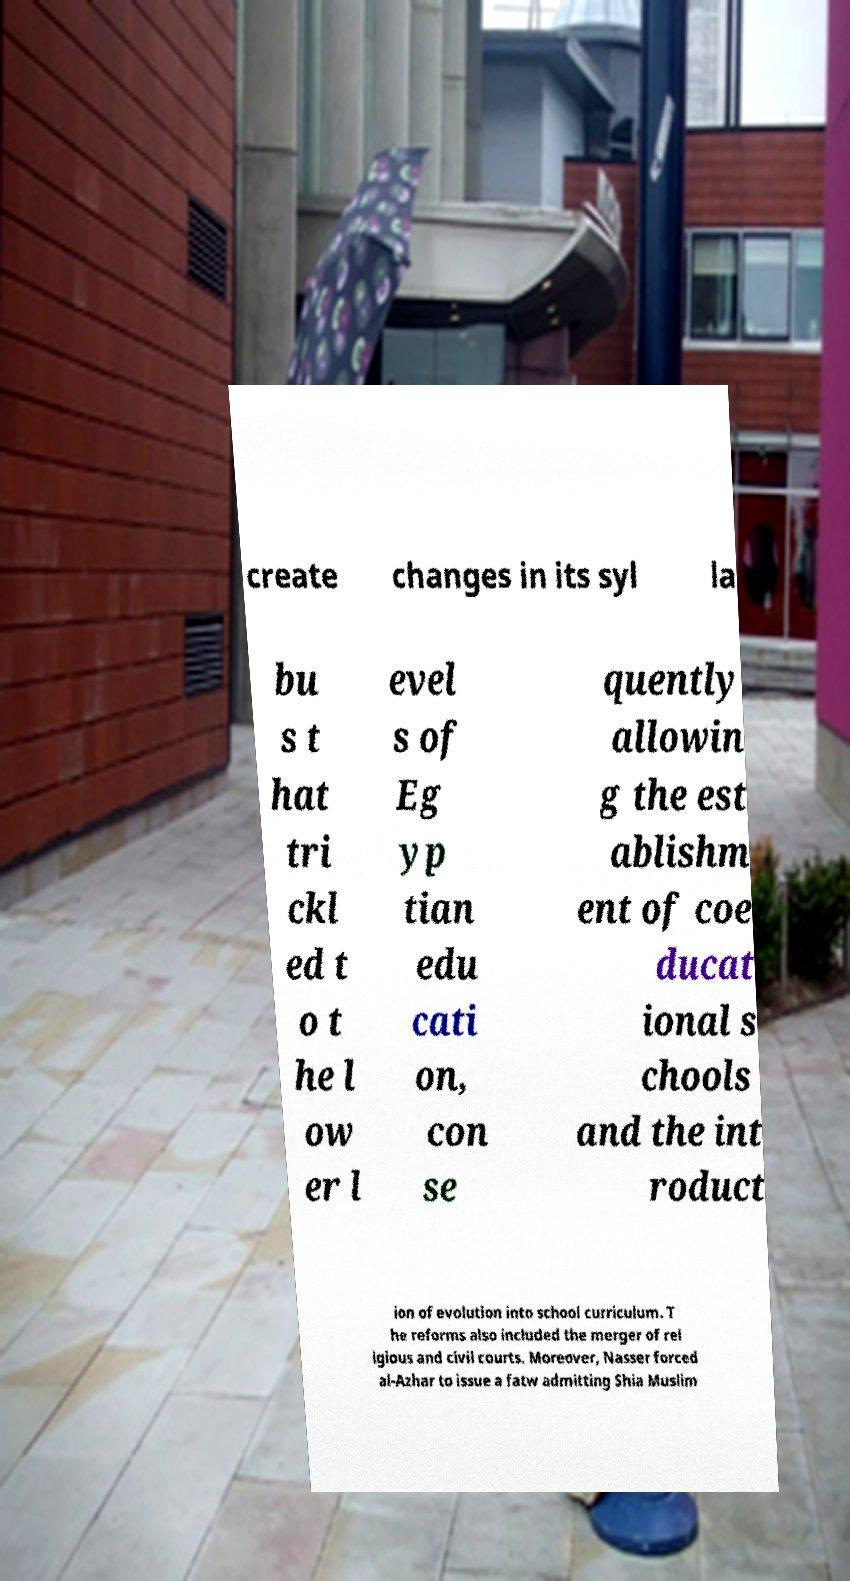I need the written content from this picture converted into text. Can you do that? create changes in its syl la bu s t hat tri ckl ed t o t he l ow er l evel s of Eg yp tian edu cati on, con se quently allowin g the est ablishm ent of coe ducat ional s chools and the int roduct ion of evolution into school curriculum. T he reforms also included the merger of rel igious and civil courts. Moreover, Nasser forced al-Azhar to issue a fatw admitting Shia Muslim 